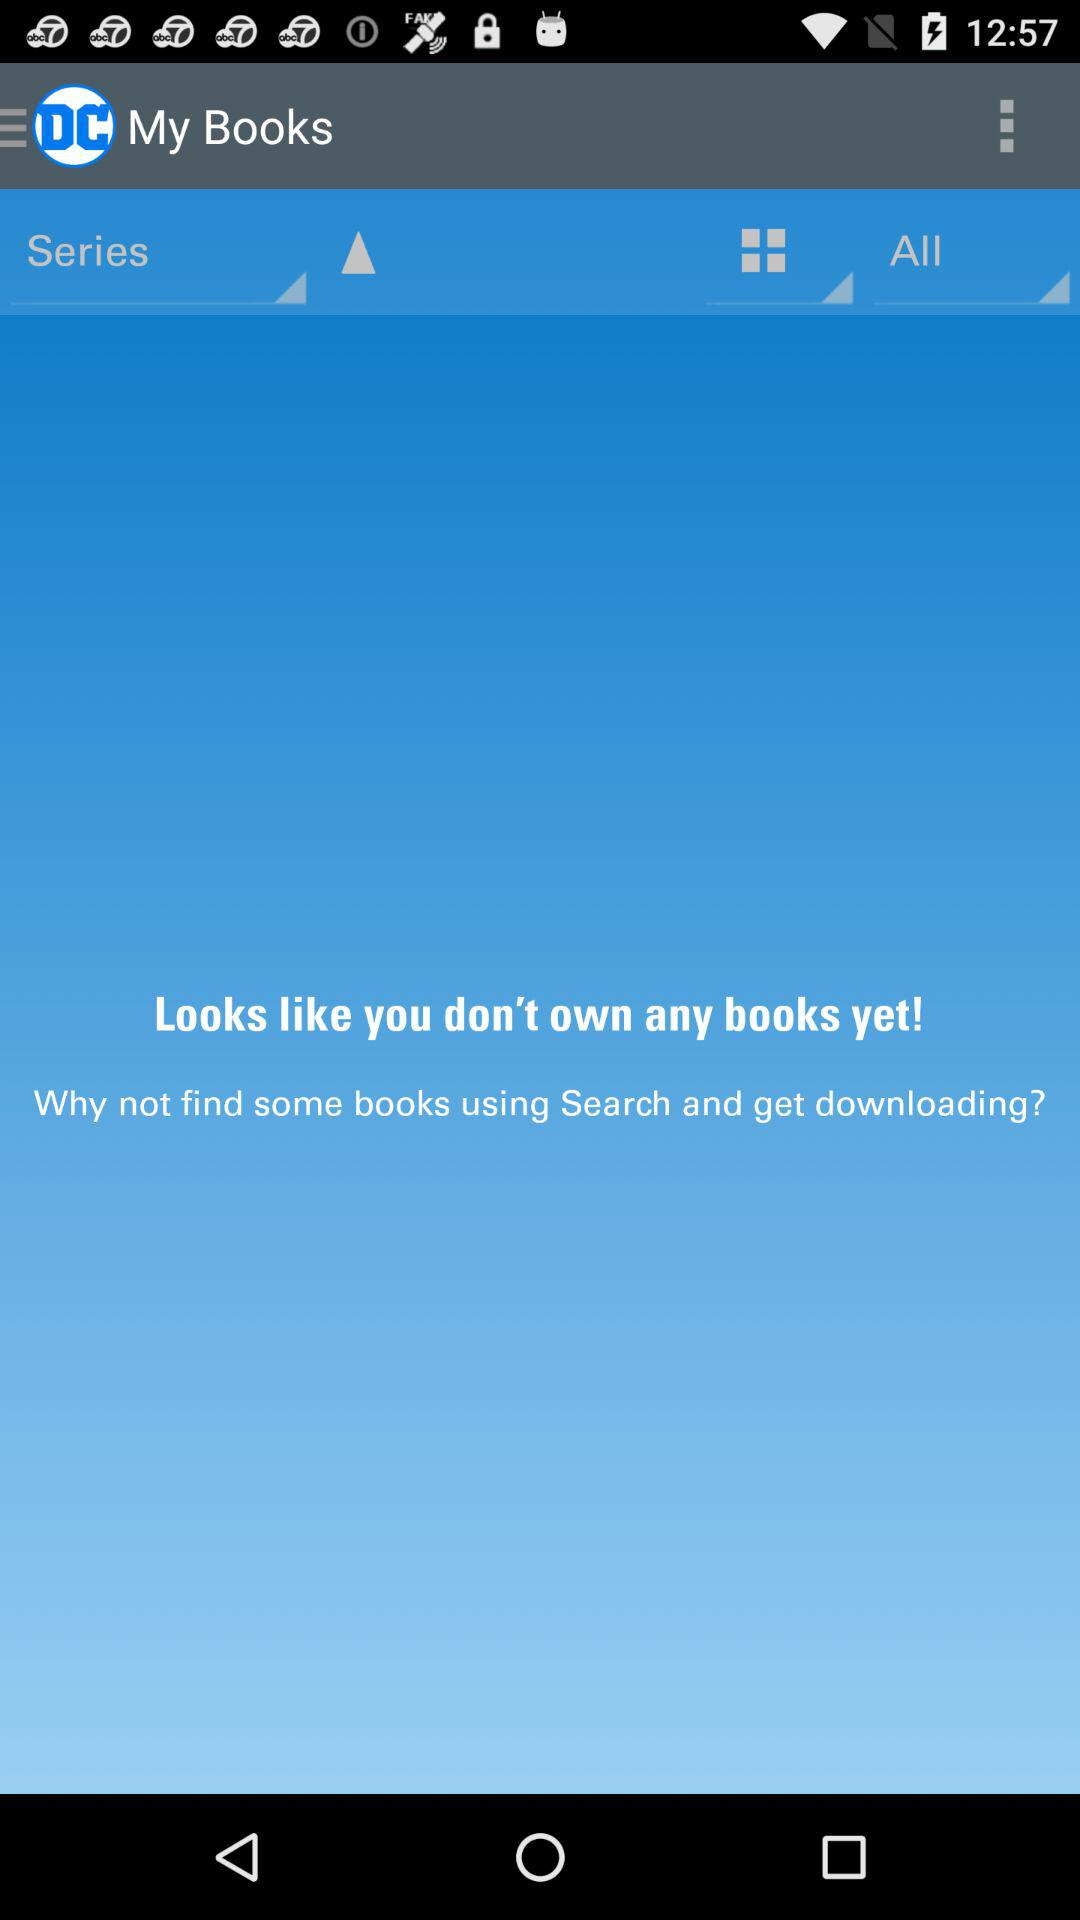What is the name of the application? The name of the application is "DC Comics". 